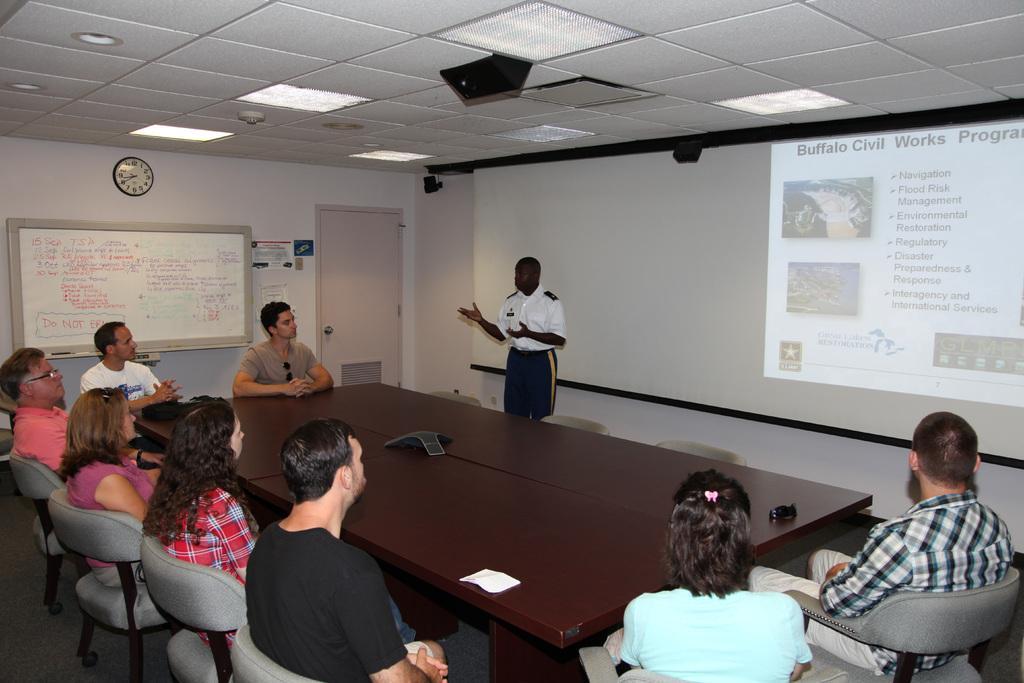How would you summarize this image in a sentence or two? This is a picture of a room where we have a white board a projector screen and a group of people sitting around a table in the chairs and a person standing in the room. 